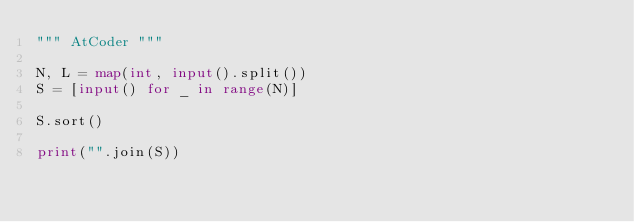Convert code to text. <code><loc_0><loc_0><loc_500><loc_500><_Python_>""" AtCoder """

N, L = map(int, input().split())
S = [input() for _ in range(N)]

S.sort()

print("".join(S))
</code> 